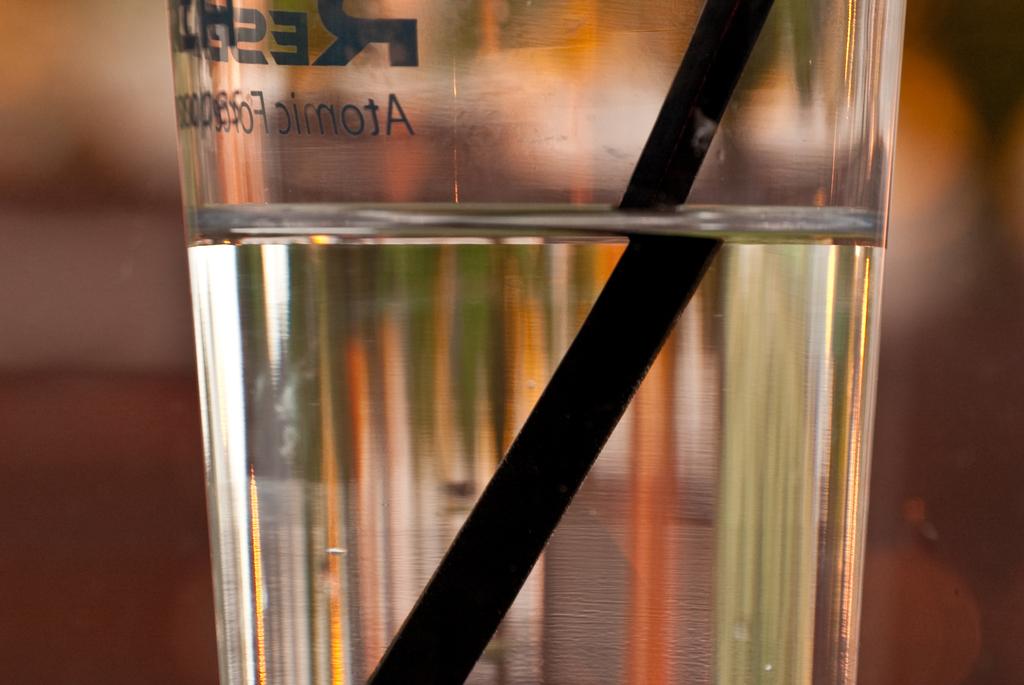Can you see the word 'atomic' written on the glass?
Your answer should be compact. Yes. What word is written on this glass?
Keep it short and to the point. Atomic. 